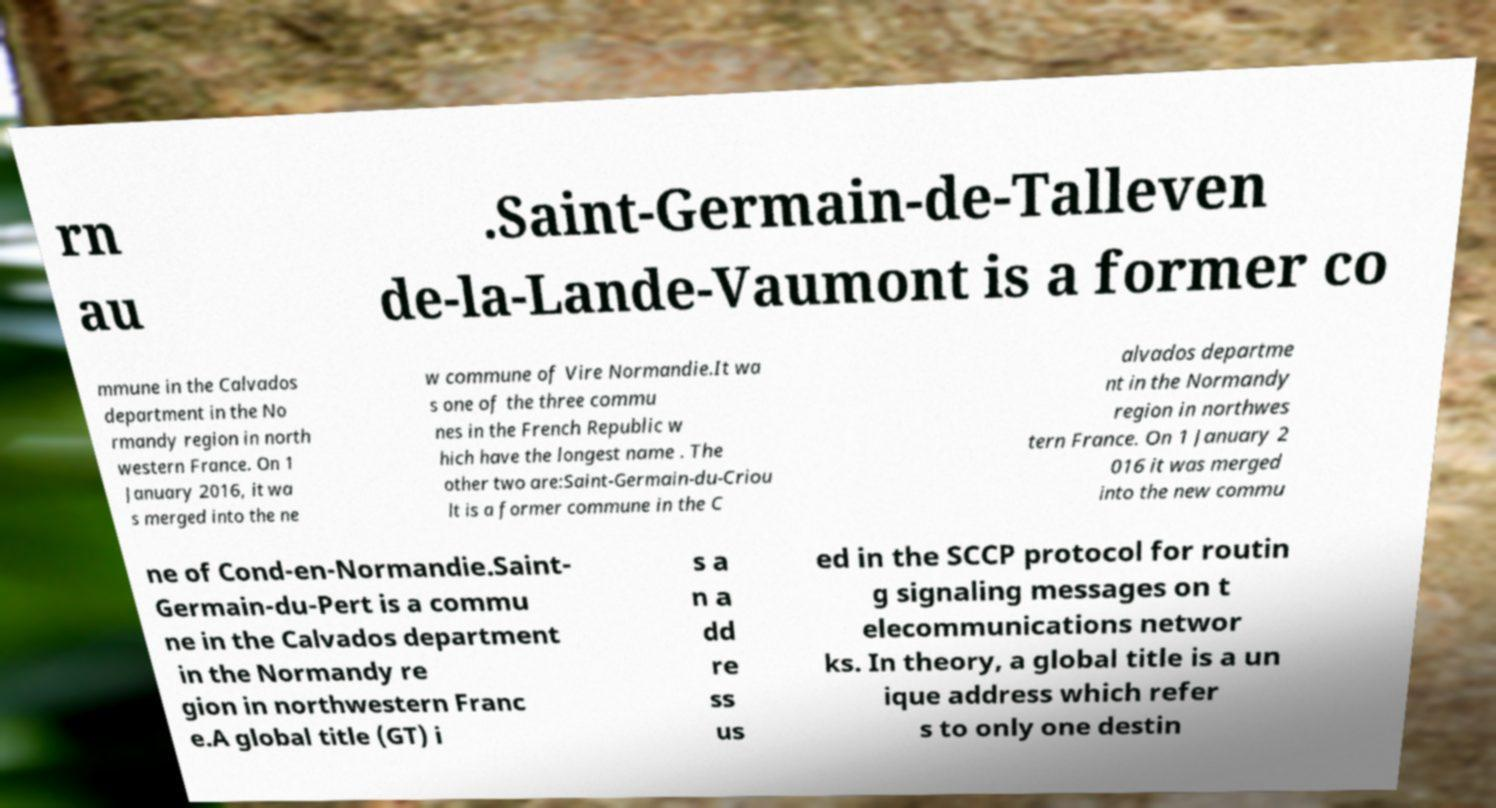I need the written content from this picture converted into text. Can you do that? rn au .Saint-Germain-de-Talleven de-la-Lande-Vaumont is a former co mmune in the Calvados department in the No rmandy region in north western France. On 1 January 2016, it wa s merged into the ne w commune of Vire Normandie.It wa s one of the three commu nes in the French Republic w hich have the longest name . The other two are:Saint-Germain-du-Criou lt is a former commune in the C alvados departme nt in the Normandy region in northwes tern France. On 1 January 2 016 it was merged into the new commu ne of Cond-en-Normandie.Saint- Germain-du-Pert is a commu ne in the Calvados department in the Normandy re gion in northwestern Franc e.A global title (GT) i s a n a dd re ss us ed in the SCCP protocol for routin g signaling messages on t elecommunications networ ks. In theory, a global title is a un ique address which refer s to only one destin 